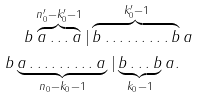Convert formula to latex. <formula><loc_0><loc_0><loc_500><loc_500>& \quad \, b \overbrace { a \dots a } ^ { n _ { 0 } ^ { \prime } - k _ { 0 } ^ { \prime } - 1 } | \overbrace { b \dots \dots \dots b } ^ { k _ { 0 } ^ { \prime } - 1 } a \\ & b \underbrace { a \dots \dots \dots a \, } _ { n _ { 0 } - k _ { 0 } - 1 } | \underbrace { b \dots b } _ { k _ { 0 } - 1 } a .</formula> 